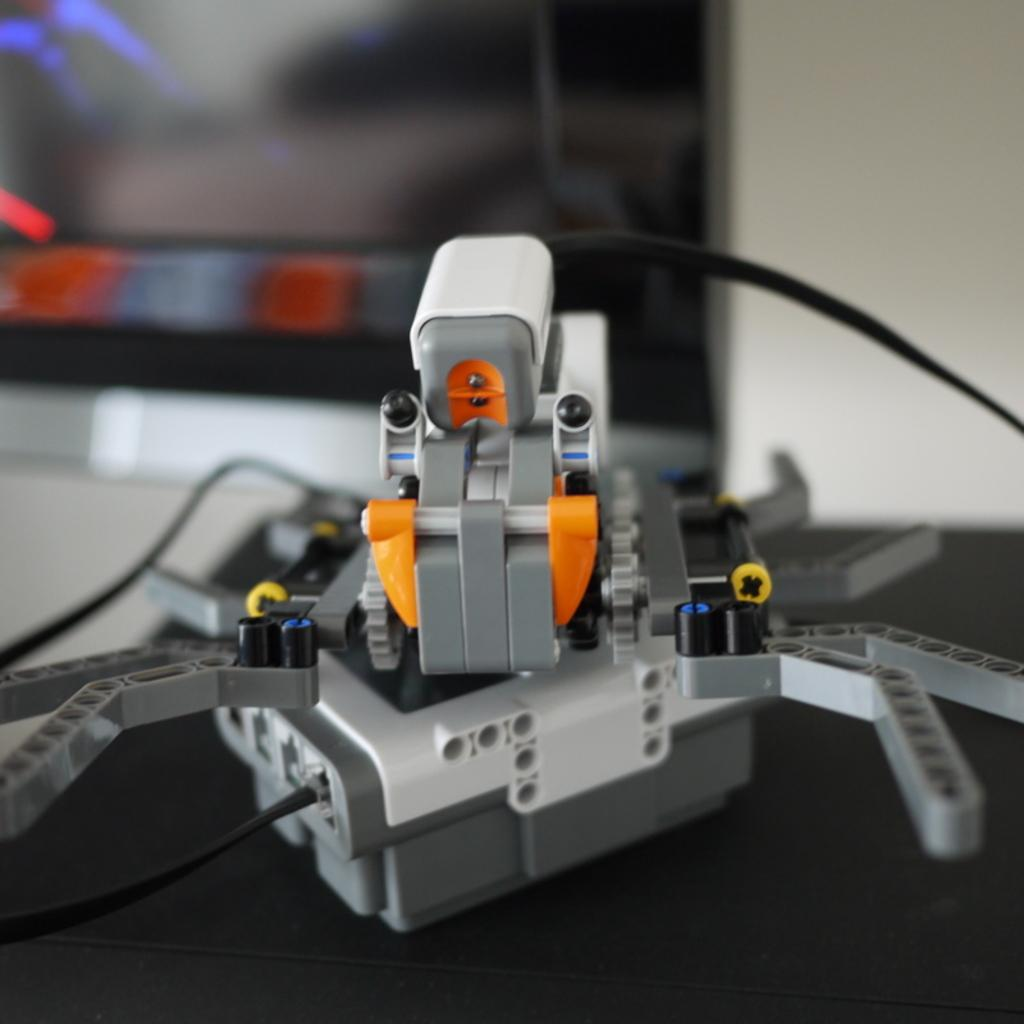What is the main object on the table in the image? Unfortunately, the provided facts do not specify the object on the table. However, we can describe the object once it is identified. Can you describe the background of the image? The background of the image is blurry. What type of garden can be seen in the image? There is no garden present in the image. What is your opinion on the beliefs of the person in the image? There is no person present in the image, and therefore no beliefs to discuss. 